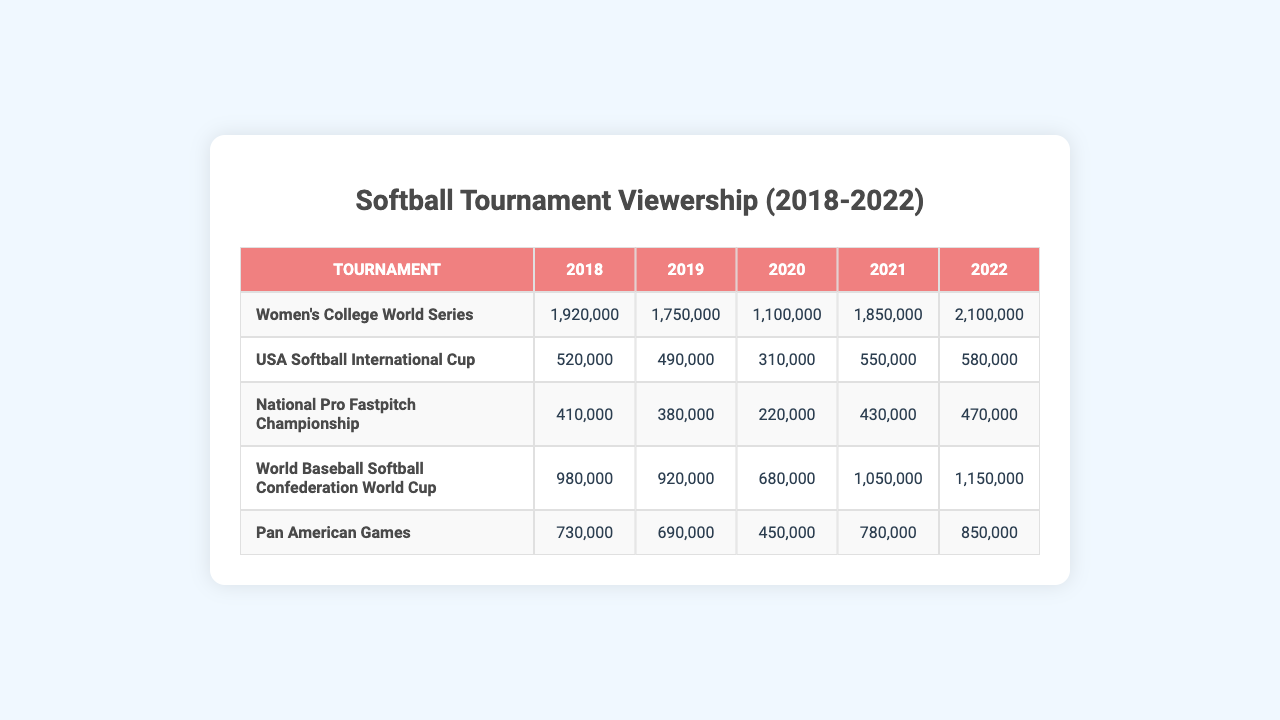What was the viewership for the Women's College World Series in 2022? In the table, the viewership for the Women's College World Series in 2022 is listed under that tournament and year, which shows 2,100,000 viewers.
Answer: 2,100,000 What is the viewership of the National Pro Fastpitch Championship in 2020? By checking the table, the viewership for the National Pro Fastpitch Championship in 2020 is shown, and it is 220,000 viewers.
Answer: 220,000 Which tournament had the highest viewership in 2019? To find out, look across all tournaments in 2019 and identify the maximum value, which is 1,750,000 for the Women's College World Series.
Answer: Women's College World Series What was the average viewership of the Pan American Games from 2018 to 2022? To calculate the average, add the viewership values for the Pan American Games during those years: (730,000 + 690,000 + 450,000 + 780,000 + 850,000) = 3,600,000. Then, divide by the number of years (5): 3,600,000 / 5 = 720,000.
Answer: 720,000 Did the USA Softball International Cup have more than 500,000 viewers in 2021? By looking at the table, the viewership for the USA Softball International Cup in 2021 is 550,000, which is indeed more than 500,000.
Answer: Yes Which tournament showed the most growth in viewership from 2018 to 2022? To determine growth, calculate the difference in viewership from 2018 to 2022 for each tournament. For instance, Women’s College World Series grew from 1,920,000 to 2,100,000, which is an increase of 180,000. The Pan American Games grew from 730,000 to 850,000, an increase of 120,000. The Women's College World Series shows the biggest increase in comparison to the others.
Answer: Women's College World Series What was the total viewership for all tournaments in 2020? Calculate the total by summing all tournament viewership for 2020: 1,100,000 (WCWS) + 310,000 (USA Softball) + 220,000 (NPF) + 680,000 (WBSC) + 450,000 (Pan American) = 2,760,000.
Answer: 2,760,000 Was the viewership for the World Baseball Softball Confederation World Cup higher in 2021 than in 2020? In the table, the viewership for the World Baseball Softball Confederation World Cup shows 1,050,000 in 2021 and 680,000 in 2020. Thus, 1,050,000 is greater than 680,000.
Answer: Yes What is the difference in viewership between the Women's College World Series and the National Pro Fastpitch Championship in 2021? From the table, the Women's College World Series had 1,850,000 viewers and the National Pro Fastpitch Championship had 430,000 viewers in 2021. The difference is 1,850,000 - 430,000 = 1,420,000.
Answer: 1,420,000 How many tournaments had viewership above 1 million in 2019? In 2019, the Women's College World Series (1,750,000) and the World Baseball Softball Confederation World Cup (920,000) had viewership above 1 million. Counting these gives a total of 2 tournaments.
Answer: 2 